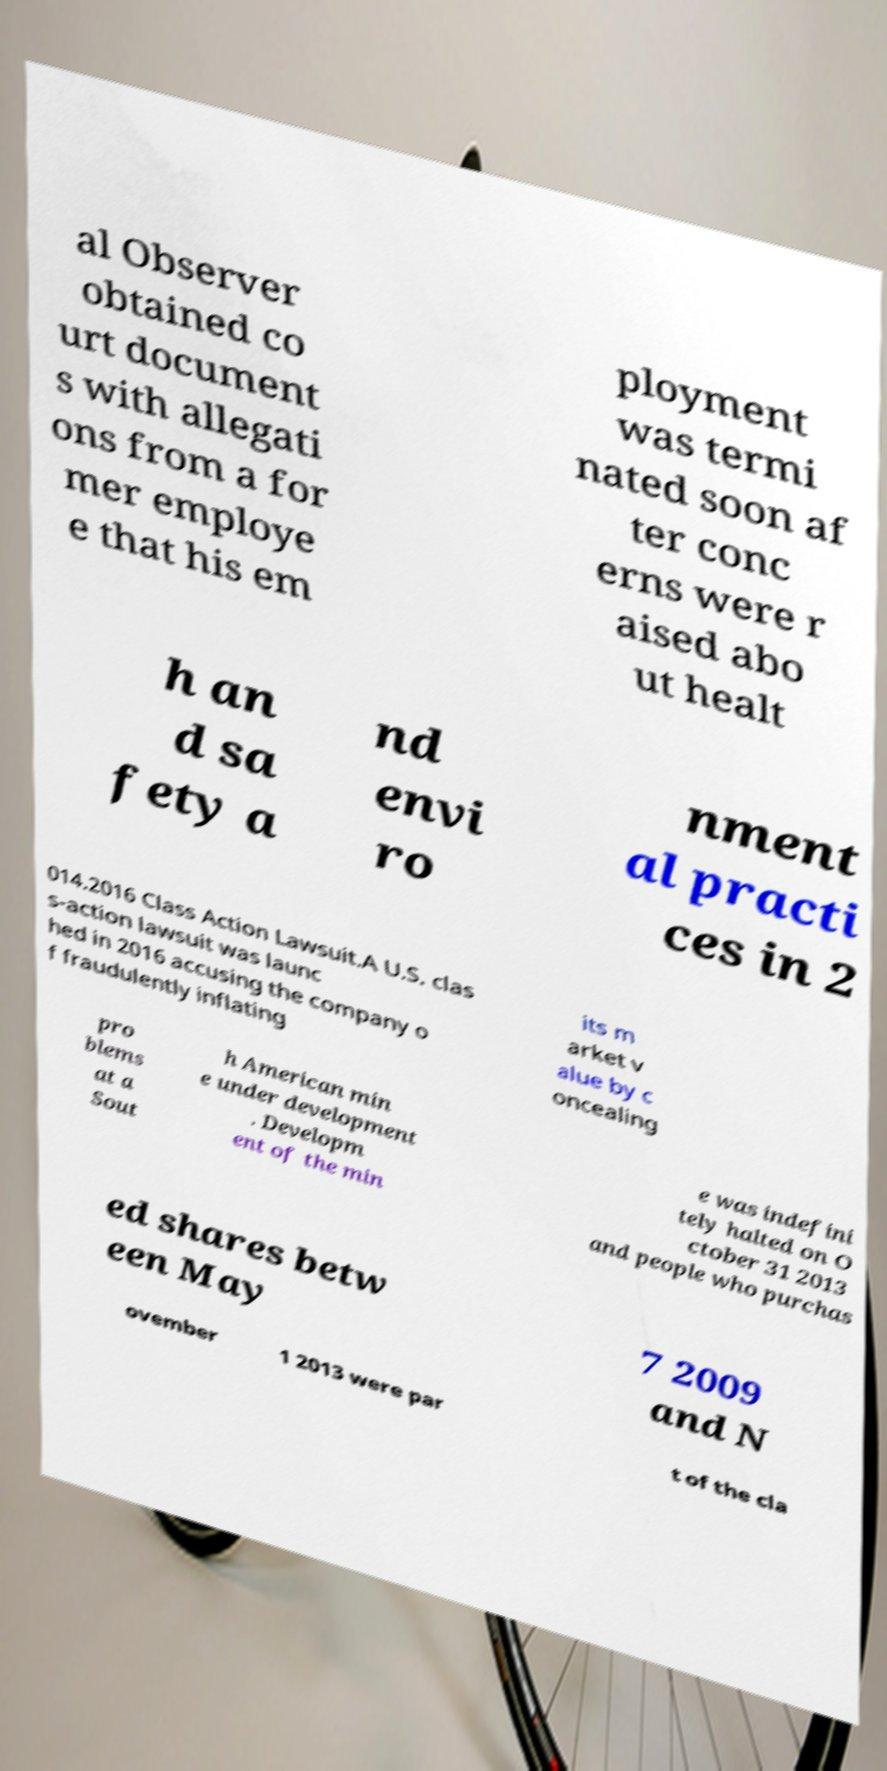There's text embedded in this image that I need extracted. Can you transcribe it verbatim? al Observer obtained co urt document s with allegati ons from a for mer employe e that his em ployment was termi nated soon af ter conc erns were r aised abo ut healt h an d sa fety a nd envi ro nment al practi ces in 2 014.2016 Class Action Lawsuit.A U.S. clas s-action lawsuit was launc hed in 2016 accusing the company o f fraudulently inflating its m arket v alue by c oncealing pro blems at a Sout h American min e under development . Developm ent of the min e was indefini tely halted on O ctober 31 2013 and people who purchas ed shares betw een May 7 2009 and N ovember 1 2013 were par t of the cla 